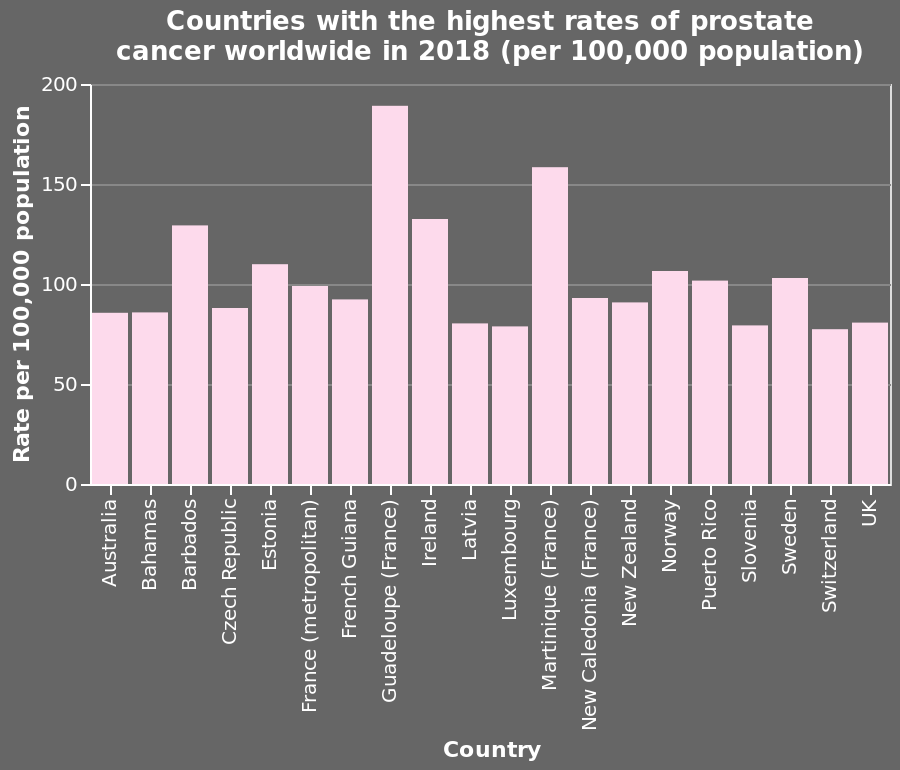<image>
What does the y-axis of the bar diagram represent? The y-axis of the bar diagram represents the rate of prostate cancer per 100,000 population. Which type of diagram is used to present the information about the countries with the highest rates of prostate cancer worldwide in 2018? A bar diagram is used to present the information about the countries with the highest rates of prostate cancer worldwide in 2018. 